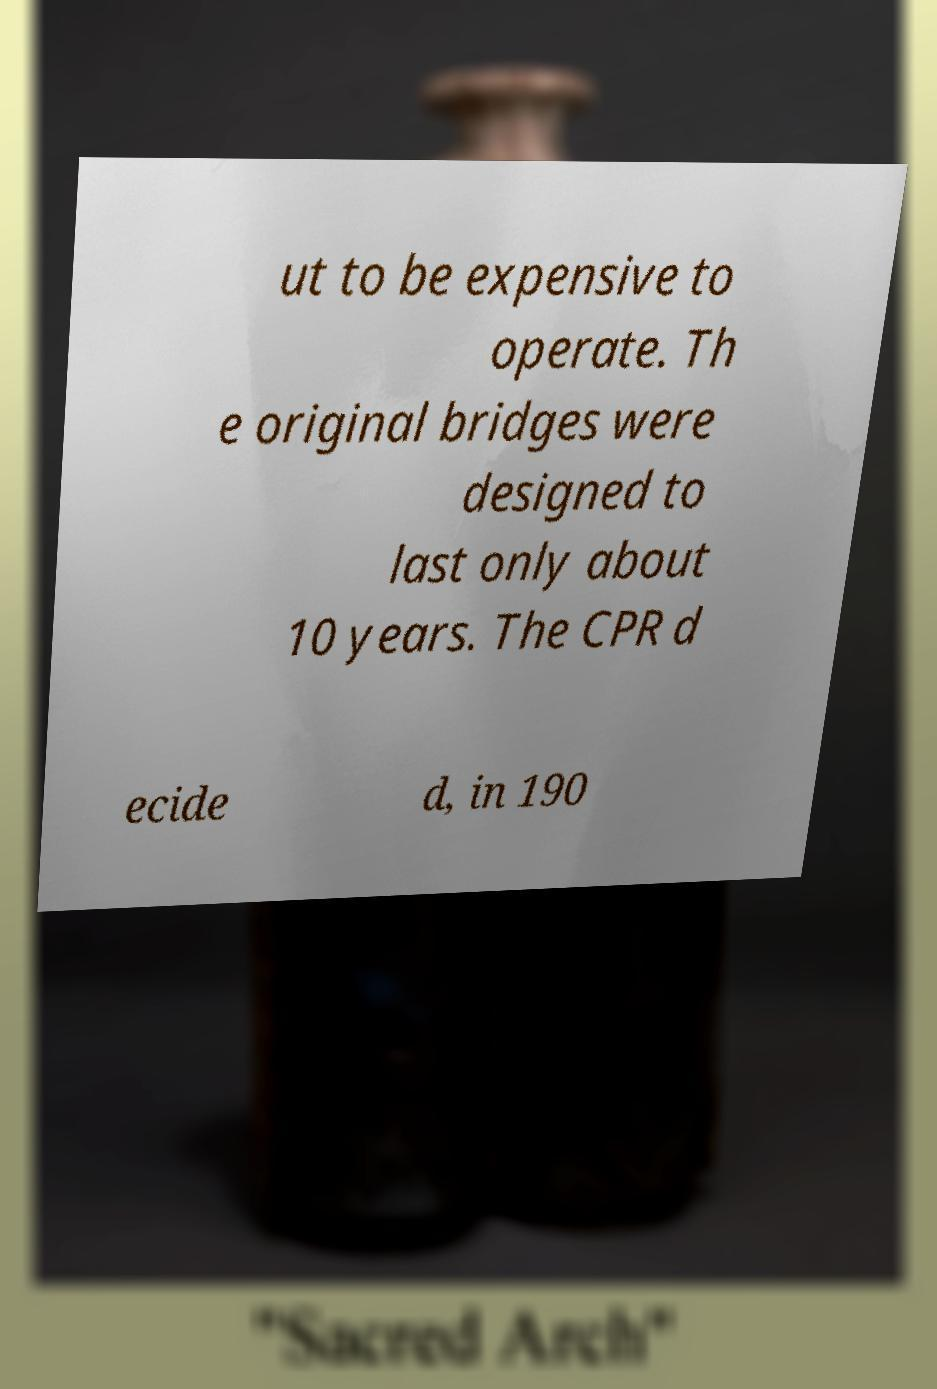Please identify and transcribe the text found in this image. ut to be expensive to operate. Th e original bridges were designed to last only about 10 years. The CPR d ecide d, in 190 